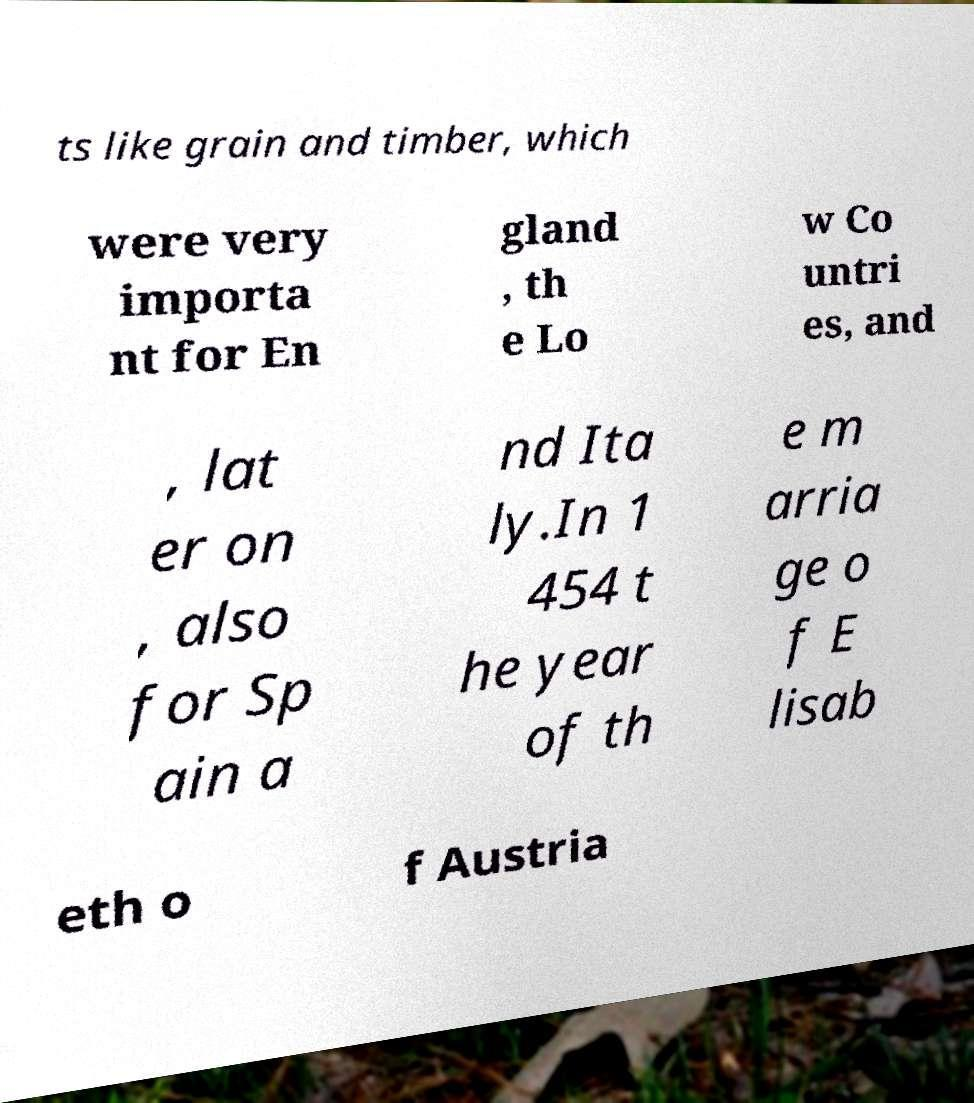Please read and relay the text visible in this image. What does it say? ts like grain and timber, which were very importa nt for En gland , th e Lo w Co untri es, and , lat er on , also for Sp ain a nd Ita ly.In 1 454 t he year of th e m arria ge o f E lisab eth o f Austria 